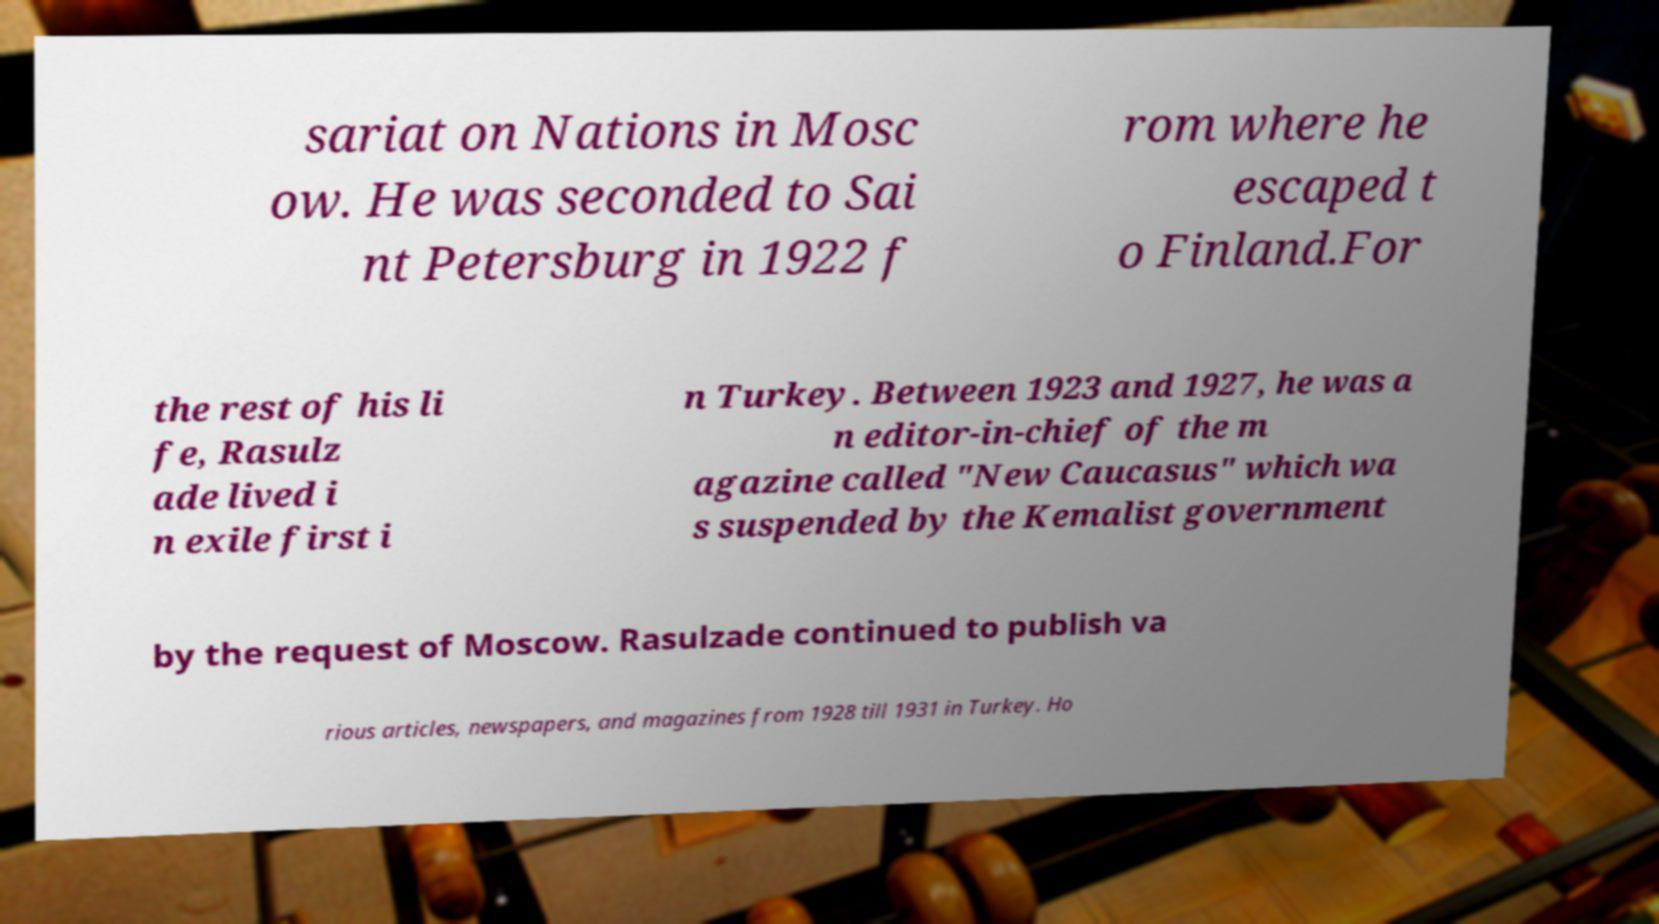I need the written content from this picture converted into text. Can you do that? sariat on Nations in Mosc ow. He was seconded to Sai nt Petersburg in 1922 f rom where he escaped t o Finland.For the rest of his li fe, Rasulz ade lived i n exile first i n Turkey. Between 1923 and 1927, he was a n editor-in-chief of the m agazine called "New Caucasus" which wa s suspended by the Kemalist government by the request of Moscow. Rasulzade continued to publish va rious articles, newspapers, and magazines from 1928 till 1931 in Turkey. Ho 